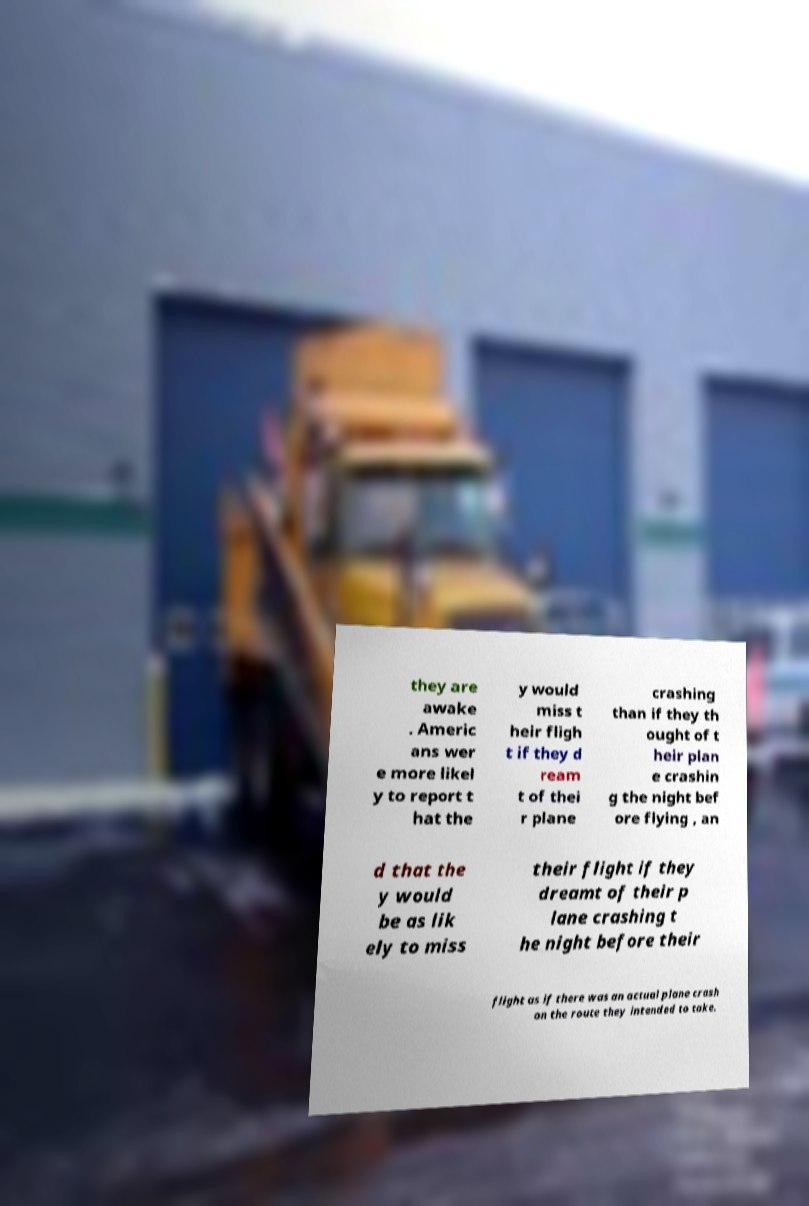Please identify and transcribe the text found in this image. they are awake . Americ ans wer e more likel y to report t hat the y would miss t heir fligh t if they d ream t of thei r plane crashing than if they th ought of t heir plan e crashin g the night bef ore flying , an d that the y would be as lik ely to miss their flight if they dreamt of their p lane crashing t he night before their flight as if there was an actual plane crash on the route they intended to take. 